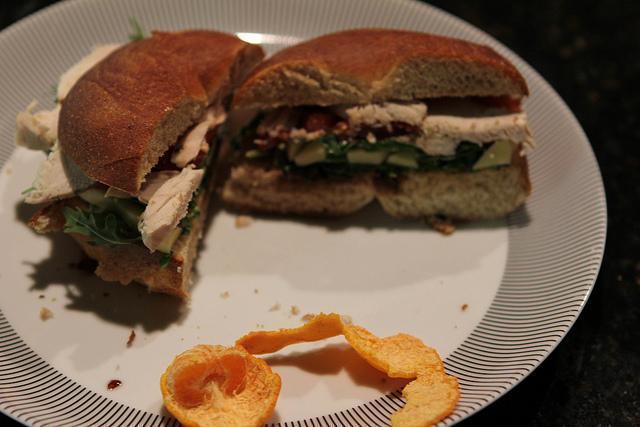Which part of this meal has a small portion?
Make your selection from the four choices given to correctly answer the question.
Options: Meat, chips, bread, veggies. Chips. 